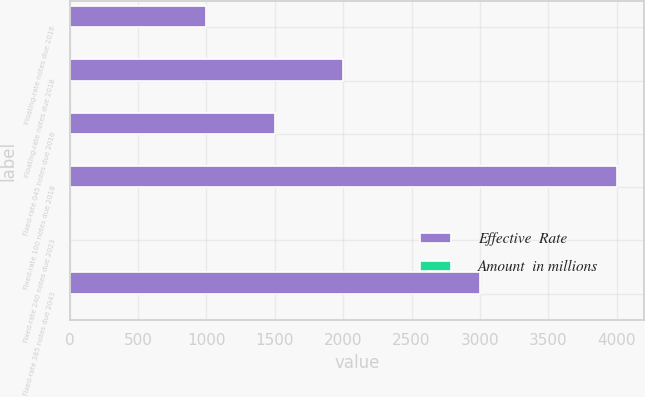Convert chart to OTSL. <chart><loc_0><loc_0><loc_500><loc_500><stacked_bar_chart><ecel><fcel>Floating-rate notes due 2016<fcel>Floating-rate notes due 2018<fcel>Fixed-rate 045 notes due 2016<fcel>Fixed-rate 100 notes due 2018<fcel>Fixed-rate 240 notes due 2023<fcel>Fixed-rate 385 notes due 2043<nl><fcel>Effective  Rate<fcel>1000<fcel>2000<fcel>1500<fcel>4000<fcel>3.91<fcel>3000<nl><fcel>Amount  in millions<fcel>0.51<fcel>1.1<fcel>0.51<fcel>1.08<fcel>2.44<fcel>3.91<nl></chart> 